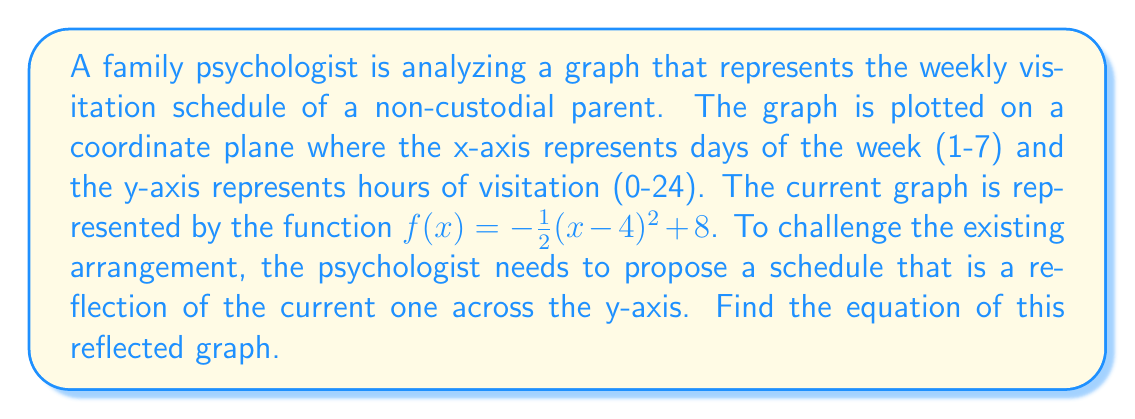Can you answer this question? To find the reflection of the graph across the y-axis, we need to apply the following steps:

1) The general form of a reflection across the y-axis is:
   If $y = f(x)$, then its reflection is $y = f(-x)$

2) Our original function is:
   $f(x) = -\frac{1}{2}(x-4)^2 + 8$

3) To reflect this, we replace every $x$ with $-x$:
   $f(-x) = -\frac{1}{2}((-x)-4)^2 + 8$

4) Simplify the expression inside the parentheses:
   $f(-x) = -\frac{1}{2}(-x-4)^2 + 8$

5) Distribute the negative sign:
   $f(-x) = -\frac{1}{2}(x+4)^2 + 8$

This is the equation of the reflected graph. It represents a schedule where the visitation hours are mirrored across the middle of the week, potentially suggesting a more balanced arrangement.
Answer: $f(-x) = -\frac{1}{2}(x+4)^2 + 8$ 